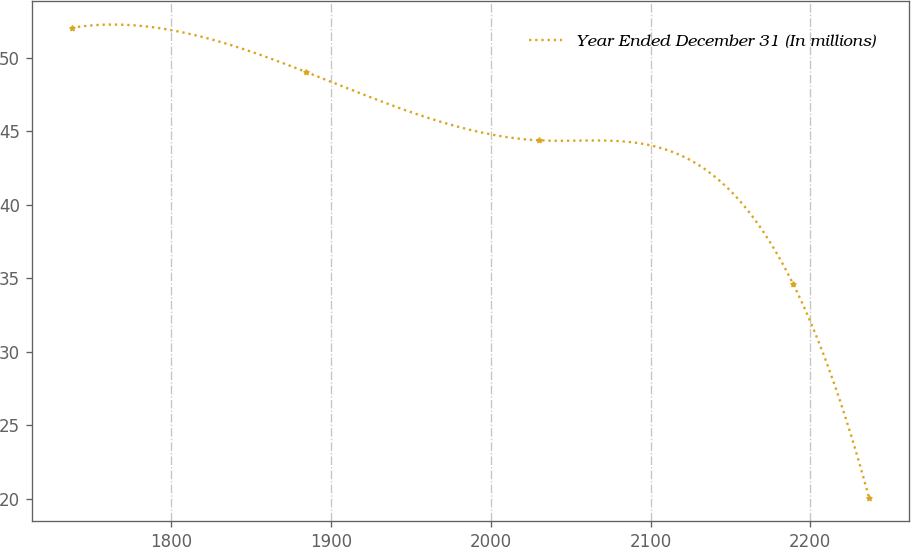Convert chart. <chart><loc_0><loc_0><loc_500><loc_500><line_chart><ecel><fcel>Year Ended December 31 (In millions)<nl><fcel>1737.72<fcel>52.05<nl><fcel>1884.22<fcel>49.05<nl><fcel>2029.96<fcel>44.39<nl><fcel>2189.16<fcel>34.64<nl><fcel>2236.8<fcel>20.06<nl></chart> 